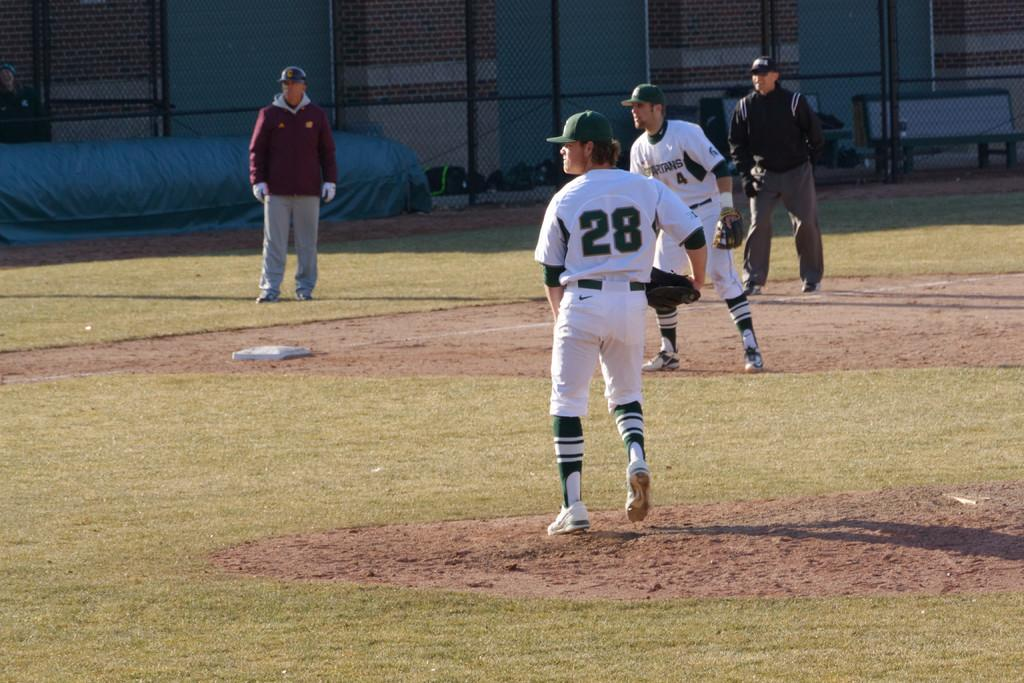<image>
Create a compact narrative representing the image presented. A baseball player wearing the number 28 watches the game as his team mate stands behind him. 